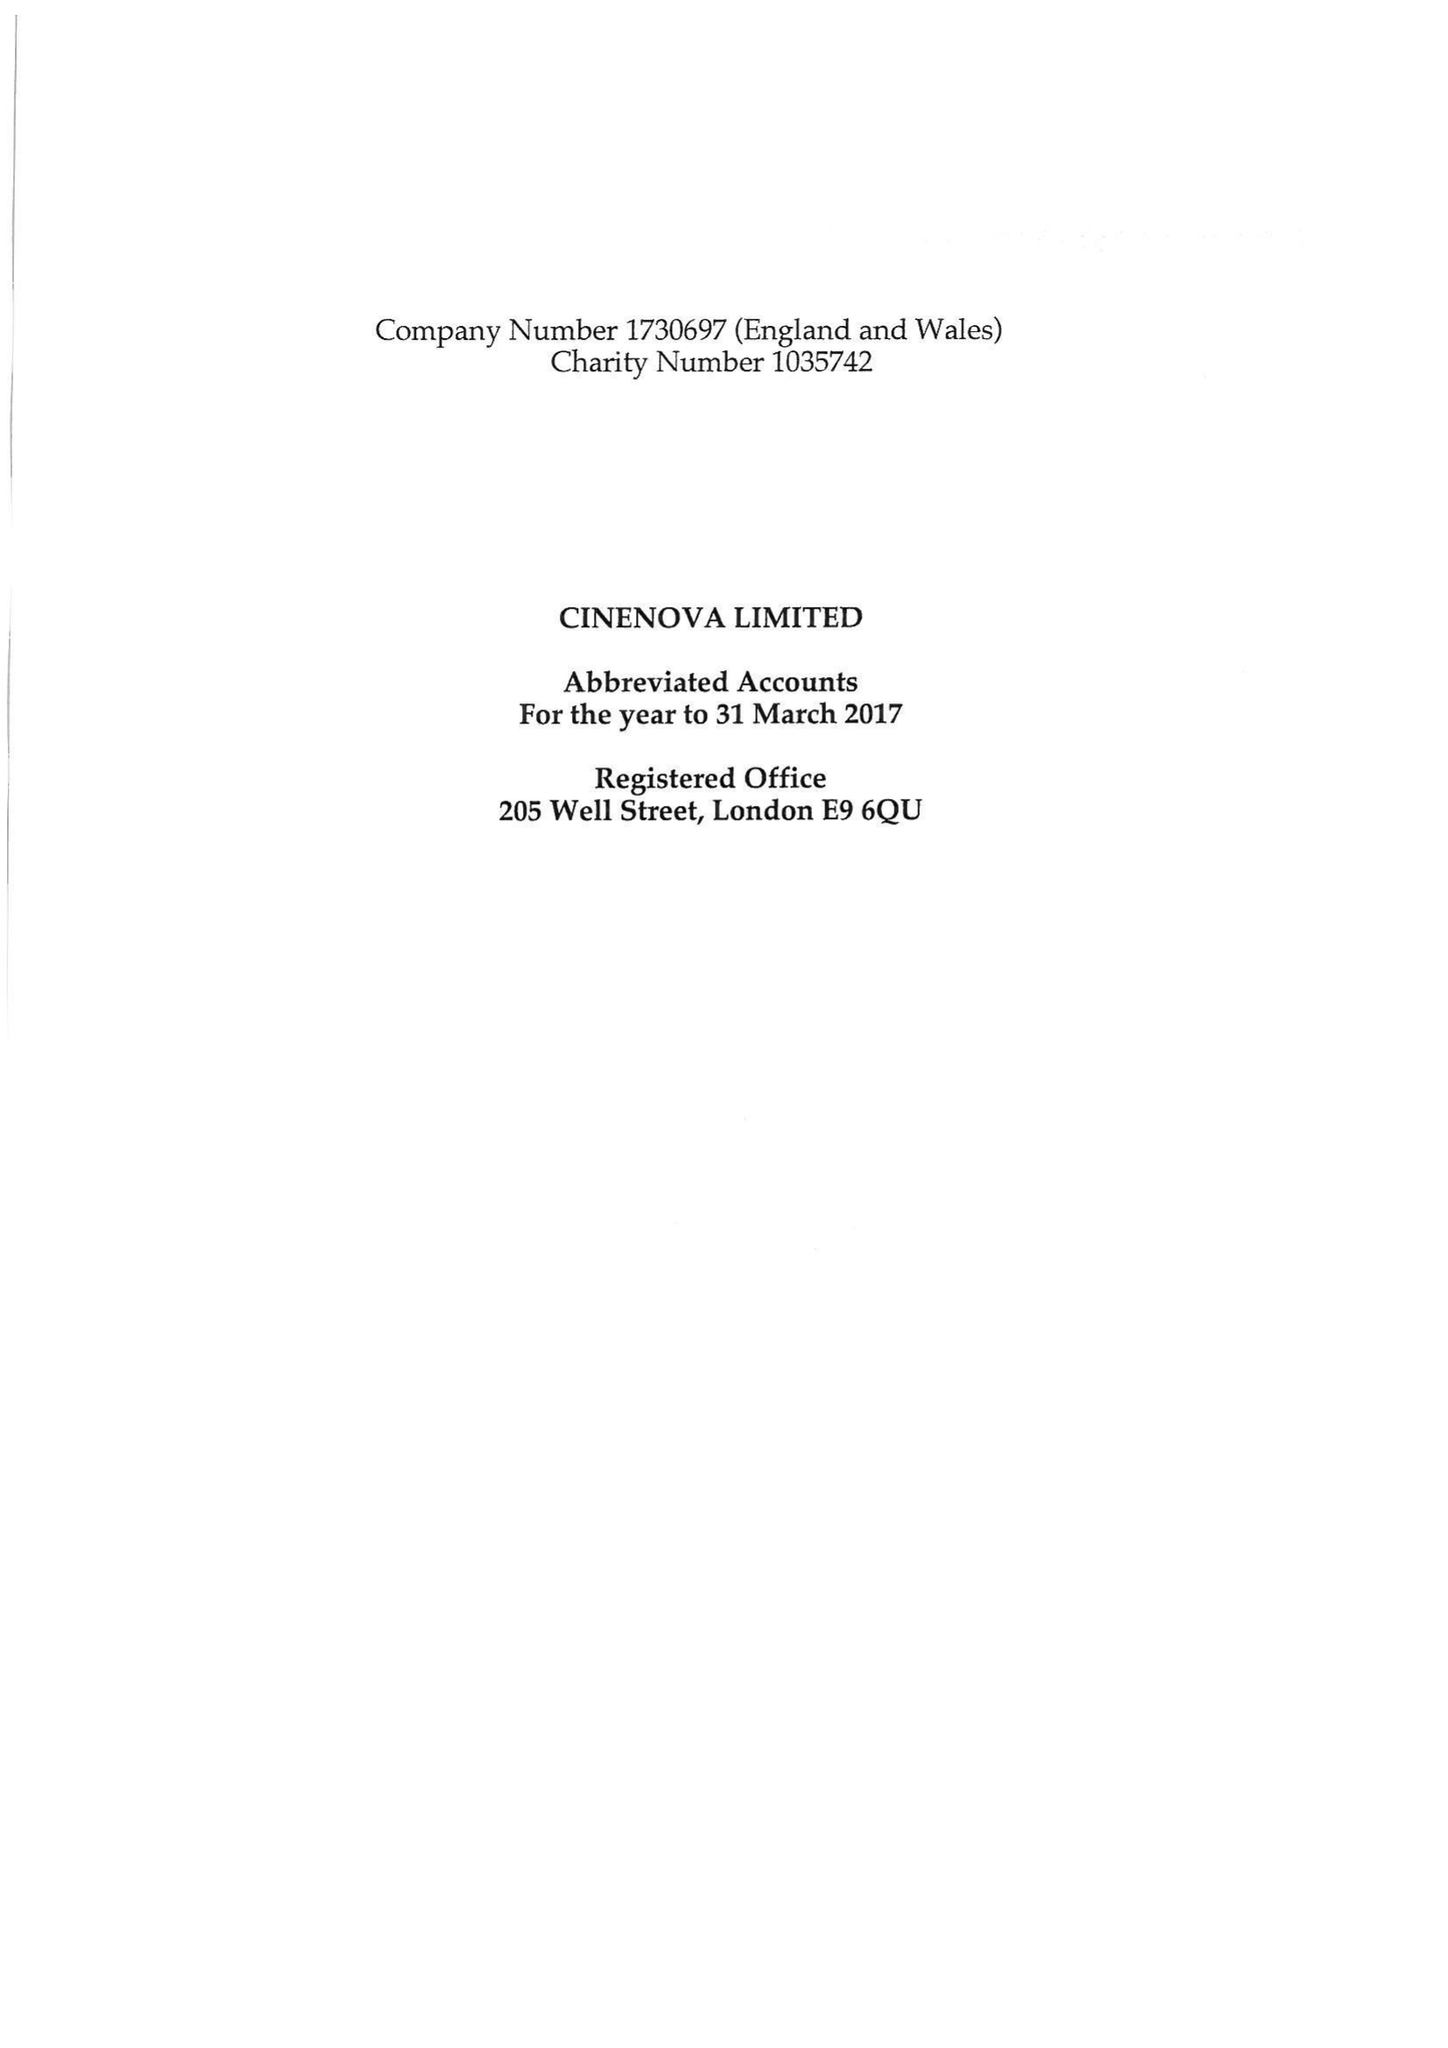What is the value for the income_annually_in_british_pounds?
Answer the question using a single word or phrase. 104026.00 